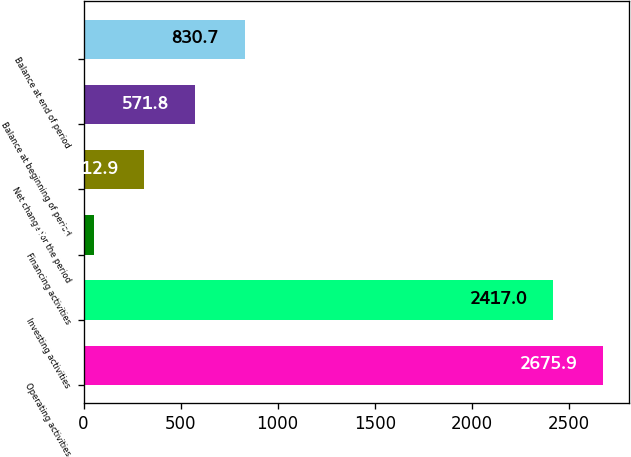Convert chart to OTSL. <chart><loc_0><loc_0><loc_500><loc_500><bar_chart><fcel>Operating activities<fcel>Investing activities<fcel>Financing activities<fcel>Net change for the period<fcel>Balance at beginning of period<fcel>Balance at end of period<nl><fcel>2675.9<fcel>2417<fcel>54<fcel>312.9<fcel>571.8<fcel>830.7<nl></chart> 